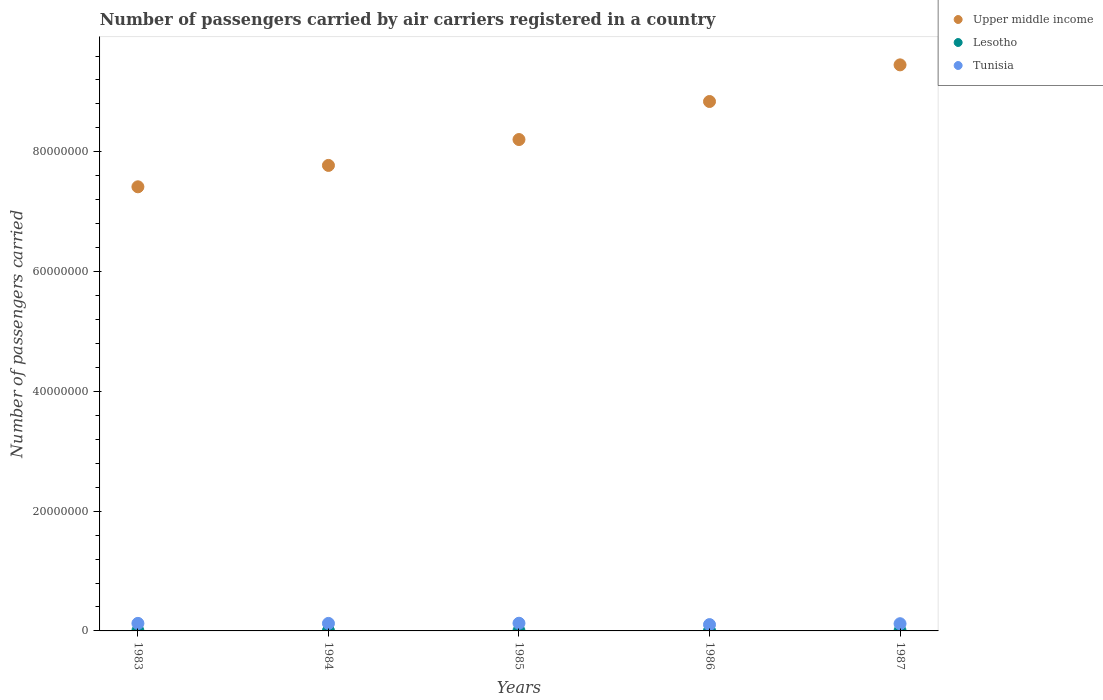Is the number of dotlines equal to the number of legend labels?
Provide a succinct answer. Yes. What is the number of passengers carried by air carriers in Tunisia in 1983?
Your answer should be compact. 1.26e+06. Across all years, what is the maximum number of passengers carried by air carriers in Upper middle income?
Your answer should be very brief. 9.45e+07. Across all years, what is the minimum number of passengers carried by air carriers in Lesotho?
Give a very brief answer. 4.87e+04. In which year was the number of passengers carried by air carriers in Tunisia maximum?
Offer a very short reply. 1985. In which year was the number of passengers carried by air carriers in Tunisia minimum?
Ensure brevity in your answer.  1986. What is the total number of passengers carried by air carriers in Lesotho in the graph?
Make the answer very short. 2.77e+05. What is the difference between the number of passengers carried by air carriers in Lesotho in 1984 and that in 1985?
Ensure brevity in your answer.  -2000. What is the difference between the number of passengers carried by air carriers in Upper middle income in 1984 and the number of passengers carried by air carriers in Tunisia in 1983?
Offer a very short reply. 7.65e+07. What is the average number of passengers carried by air carriers in Tunisia per year?
Offer a terse response. 1.21e+06. In the year 1984, what is the difference between the number of passengers carried by air carriers in Upper middle income and number of passengers carried by air carriers in Lesotho?
Keep it short and to the point. 7.77e+07. In how many years, is the number of passengers carried by air carriers in Upper middle income greater than 92000000?
Offer a very short reply. 1. What is the ratio of the number of passengers carried by air carriers in Lesotho in 1983 to that in 1985?
Your response must be concise. 1.2. Is the difference between the number of passengers carried by air carriers in Upper middle income in 1985 and 1987 greater than the difference between the number of passengers carried by air carriers in Lesotho in 1985 and 1987?
Make the answer very short. No. What is the difference between the highest and the lowest number of passengers carried by air carriers in Tunisia?
Make the answer very short. 2.27e+05. Is it the case that in every year, the sum of the number of passengers carried by air carriers in Lesotho and number of passengers carried by air carriers in Tunisia  is greater than the number of passengers carried by air carriers in Upper middle income?
Give a very brief answer. No. Does the number of passengers carried by air carriers in Lesotho monotonically increase over the years?
Provide a succinct answer. No. Is the number of passengers carried by air carriers in Upper middle income strictly less than the number of passengers carried by air carriers in Tunisia over the years?
Provide a succinct answer. No. How many years are there in the graph?
Provide a short and direct response. 5. What is the difference between two consecutive major ticks on the Y-axis?
Your answer should be compact. 2.00e+07. Are the values on the major ticks of Y-axis written in scientific E-notation?
Make the answer very short. No. Does the graph contain any zero values?
Give a very brief answer. No. Does the graph contain grids?
Offer a terse response. No. Where does the legend appear in the graph?
Offer a very short reply. Top right. How many legend labels are there?
Your answer should be compact. 3. How are the legend labels stacked?
Give a very brief answer. Vertical. What is the title of the graph?
Your response must be concise. Number of passengers carried by air carriers registered in a country. What is the label or title of the X-axis?
Your answer should be very brief. Years. What is the label or title of the Y-axis?
Provide a succinct answer. Number of passengers carried. What is the Number of passengers carried in Upper middle income in 1983?
Offer a very short reply. 7.42e+07. What is the Number of passengers carried of Lesotho in 1983?
Your answer should be very brief. 6.10e+04. What is the Number of passengers carried in Tunisia in 1983?
Keep it short and to the point. 1.26e+06. What is the Number of passengers carried in Upper middle income in 1984?
Provide a short and direct response. 7.77e+07. What is the Number of passengers carried in Lesotho in 1984?
Your answer should be compact. 4.87e+04. What is the Number of passengers carried of Tunisia in 1984?
Your answer should be very brief. 1.25e+06. What is the Number of passengers carried in Upper middle income in 1985?
Make the answer very short. 8.21e+07. What is the Number of passengers carried of Lesotho in 1985?
Ensure brevity in your answer.  5.07e+04. What is the Number of passengers carried of Tunisia in 1985?
Your answer should be compact. 1.28e+06. What is the Number of passengers carried of Upper middle income in 1986?
Provide a short and direct response. 8.84e+07. What is the Number of passengers carried of Lesotho in 1986?
Offer a terse response. 5.53e+04. What is the Number of passengers carried of Tunisia in 1986?
Give a very brief answer. 1.05e+06. What is the Number of passengers carried in Upper middle income in 1987?
Offer a very short reply. 9.45e+07. What is the Number of passengers carried of Lesotho in 1987?
Provide a short and direct response. 6.09e+04. What is the Number of passengers carried in Tunisia in 1987?
Offer a very short reply. 1.20e+06. Across all years, what is the maximum Number of passengers carried in Upper middle income?
Your answer should be compact. 9.45e+07. Across all years, what is the maximum Number of passengers carried in Lesotho?
Ensure brevity in your answer.  6.10e+04. Across all years, what is the maximum Number of passengers carried of Tunisia?
Offer a terse response. 1.28e+06. Across all years, what is the minimum Number of passengers carried in Upper middle income?
Offer a very short reply. 7.42e+07. Across all years, what is the minimum Number of passengers carried of Lesotho?
Keep it short and to the point. 4.87e+04. Across all years, what is the minimum Number of passengers carried in Tunisia?
Your answer should be compact. 1.05e+06. What is the total Number of passengers carried of Upper middle income in the graph?
Your response must be concise. 4.17e+08. What is the total Number of passengers carried in Lesotho in the graph?
Ensure brevity in your answer.  2.77e+05. What is the total Number of passengers carried in Tunisia in the graph?
Offer a terse response. 6.05e+06. What is the difference between the Number of passengers carried in Upper middle income in 1983 and that in 1984?
Your response must be concise. -3.57e+06. What is the difference between the Number of passengers carried in Lesotho in 1983 and that in 1984?
Keep it short and to the point. 1.23e+04. What is the difference between the Number of passengers carried in Tunisia in 1983 and that in 1984?
Provide a succinct answer. 3200. What is the difference between the Number of passengers carried in Upper middle income in 1983 and that in 1985?
Offer a terse response. -7.89e+06. What is the difference between the Number of passengers carried in Lesotho in 1983 and that in 1985?
Provide a succinct answer. 1.03e+04. What is the difference between the Number of passengers carried of Tunisia in 1983 and that in 1985?
Your answer should be compact. -2.35e+04. What is the difference between the Number of passengers carried of Upper middle income in 1983 and that in 1986?
Your answer should be compact. -1.42e+07. What is the difference between the Number of passengers carried of Lesotho in 1983 and that in 1986?
Provide a short and direct response. 5700. What is the difference between the Number of passengers carried of Tunisia in 1983 and that in 1986?
Give a very brief answer. 2.03e+05. What is the difference between the Number of passengers carried in Upper middle income in 1983 and that in 1987?
Provide a short and direct response. -2.04e+07. What is the difference between the Number of passengers carried in Lesotho in 1983 and that in 1987?
Offer a very short reply. 100. What is the difference between the Number of passengers carried of Tunisia in 1983 and that in 1987?
Make the answer very short. 5.48e+04. What is the difference between the Number of passengers carried in Upper middle income in 1984 and that in 1985?
Your response must be concise. -4.32e+06. What is the difference between the Number of passengers carried of Lesotho in 1984 and that in 1985?
Give a very brief answer. -2000. What is the difference between the Number of passengers carried in Tunisia in 1984 and that in 1985?
Give a very brief answer. -2.67e+04. What is the difference between the Number of passengers carried of Upper middle income in 1984 and that in 1986?
Provide a succinct answer. -1.07e+07. What is the difference between the Number of passengers carried of Lesotho in 1984 and that in 1986?
Your answer should be very brief. -6600. What is the difference between the Number of passengers carried of Tunisia in 1984 and that in 1986?
Offer a very short reply. 2.00e+05. What is the difference between the Number of passengers carried in Upper middle income in 1984 and that in 1987?
Your response must be concise. -1.68e+07. What is the difference between the Number of passengers carried of Lesotho in 1984 and that in 1987?
Your answer should be very brief. -1.22e+04. What is the difference between the Number of passengers carried of Tunisia in 1984 and that in 1987?
Keep it short and to the point. 5.16e+04. What is the difference between the Number of passengers carried in Upper middle income in 1985 and that in 1986?
Your response must be concise. -6.35e+06. What is the difference between the Number of passengers carried of Lesotho in 1985 and that in 1986?
Provide a short and direct response. -4600. What is the difference between the Number of passengers carried of Tunisia in 1985 and that in 1986?
Make the answer very short. 2.27e+05. What is the difference between the Number of passengers carried in Upper middle income in 1985 and that in 1987?
Your answer should be very brief. -1.25e+07. What is the difference between the Number of passengers carried in Lesotho in 1985 and that in 1987?
Your answer should be compact. -1.02e+04. What is the difference between the Number of passengers carried of Tunisia in 1985 and that in 1987?
Offer a terse response. 7.83e+04. What is the difference between the Number of passengers carried in Upper middle income in 1986 and that in 1987?
Offer a very short reply. -6.12e+06. What is the difference between the Number of passengers carried of Lesotho in 1986 and that in 1987?
Give a very brief answer. -5600. What is the difference between the Number of passengers carried of Tunisia in 1986 and that in 1987?
Your response must be concise. -1.48e+05. What is the difference between the Number of passengers carried of Upper middle income in 1983 and the Number of passengers carried of Lesotho in 1984?
Ensure brevity in your answer.  7.41e+07. What is the difference between the Number of passengers carried in Upper middle income in 1983 and the Number of passengers carried in Tunisia in 1984?
Provide a short and direct response. 7.29e+07. What is the difference between the Number of passengers carried in Lesotho in 1983 and the Number of passengers carried in Tunisia in 1984?
Your response must be concise. -1.19e+06. What is the difference between the Number of passengers carried of Upper middle income in 1983 and the Number of passengers carried of Lesotho in 1985?
Offer a very short reply. 7.41e+07. What is the difference between the Number of passengers carried of Upper middle income in 1983 and the Number of passengers carried of Tunisia in 1985?
Offer a terse response. 7.29e+07. What is the difference between the Number of passengers carried of Lesotho in 1983 and the Number of passengers carried of Tunisia in 1985?
Make the answer very short. -1.22e+06. What is the difference between the Number of passengers carried in Upper middle income in 1983 and the Number of passengers carried in Lesotho in 1986?
Provide a short and direct response. 7.41e+07. What is the difference between the Number of passengers carried in Upper middle income in 1983 and the Number of passengers carried in Tunisia in 1986?
Provide a short and direct response. 7.31e+07. What is the difference between the Number of passengers carried of Lesotho in 1983 and the Number of passengers carried of Tunisia in 1986?
Provide a succinct answer. -9.94e+05. What is the difference between the Number of passengers carried in Upper middle income in 1983 and the Number of passengers carried in Lesotho in 1987?
Your answer should be very brief. 7.41e+07. What is the difference between the Number of passengers carried in Upper middle income in 1983 and the Number of passengers carried in Tunisia in 1987?
Your response must be concise. 7.30e+07. What is the difference between the Number of passengers carried in Lesotho in 1983 and the Number of passengers carried in Tunisia in 1987?
Give a very brief answer. -1.14e+06. What is the difference between the Number of passengers carried in Upper middle income in 1984 and the Number of passengers carried in Lesotho in 1985?
Offer a terse response. 7.77e+07. What is the difference between the Number of passengers carried of Upper middle income in 1984 and the Number of passengers carried of Tunisia in 1985?
Provide a succinct answer. 7.65e+07. What is the difference between the Number of passengers carried in Lesotho in 1984 and the Number of passengers carried in Tunisia in 1985?
Provide a short and direct response. -1.23e+06. What is the difference between the Number of passengers carried in Upper middle income in 1984 and the Number of passengers carried in Lesotho in 1986?
Your response must be concise. 7.77e+07. What is the difference between the Number of passengers carried in Upper middle income in 1984 and the Number of passengers carried in Tunisia in 1986?
Your answer should be very brief. 7.67e+07. What is the difference between the Number of passengers carried of Lesotho in 1984 and the Number of passengers carried of Tunisia in 1986?
Your answer should be very brief. -1.01e+06. What is the difference between the Number of passengers carried of Upper middle income in 1984 and the Number of passengers carried of Lesotho in 1987?
Make the answer very short. 7.77e+07. What is the difference between the Number of passengers carried in Upper middle income in 1984 and the Number of passengers carried in Tunisia in 1987?
Give a very brief answer. 7.65e+07. What is the difference between the Number of passengers carried of Lesotho in 1984 and the Number of passengers carried of Tunisia in 1987?
Give a very brief answer. -1.15e+06. What is the difference between the Number of passengers carried in Upper middle income in 1985 and the Number of passengers carried in Lesotho in 1986?
Offer a terse response. 8.20e+07. What is the difference between the Number of passengers carried of Upper middle income in 1985 and the Number of passengers carried of Tunisia in 1986?
Provide a succinct answer. 8.10e+07. What is the difference between the Number of passengers carried in Lesotho in 1985 and the Number of passengers carried in Tunisia in 1986?
Give a very brief answer. -1.00e+06. What is the difference between the Number of passengers carried of Upper middle income in 1985 and the Number of passengers carried of Lesotho in 1987?
Offer a terse response. 8.20e+07. What is the difference between the Number of passengers carried in Upper middle income in 1985 and the Number of passengers carried in Tunisia in 1987?
Your answer should be very brief. 8.08e+07. What is the difference between the Number of passengers carried in Lesotho in 1985 and the Number of passengers carried in Tunisia in 1987?
Keep it short and to the point. -1.15e+06. What is the difference between the Number of passengers carried in Upper middle income in 1986 and the Number of passengers carried in Lesotho in 1987?
Provide a succinct answer. 8.83e+07. What is the difference between the Number of passengers carried in Upper middle income in 1986 and the Number of passengers carried in Tunisia in 1987?
Your response must be concise. 8.72e+07. What is the difference between the Number of passengers carried of Lesotho in 1986 and the Number of passengers carried of Tunisia in 1987?
Give a very brief answer. -1.15e+06. What is the average Number of passengers carried in Upper middle income per year?
Keep it short and to the point. 8.34e+07. What is the average Number of passengers carried in Lesotho per year?
Provide a succinct answer. 5.53e+04. What is the average Number of passengers carried in Tunisia per year?
Give a very brief answer. 1.21e+06. In the year 1983, what is the difference between the Number of passengers carried in Upper middle income and Number of passengers carried in Lesotho?
Your response must be concise. 7.41e+07. In the year 1983, what is the difference between the Number of passengers carried in Upper middle income and Number of passengers carried in Tunisia?
Provide a short and direct response. 7.29e+07. In the year 1983, what is the difference between the Number of passengers carried in Lesotho and Number of passengers carried in Tunisia?
Provide a succinct answer. -1.20e+06. In the year 1984, what is the difference between the Number of passengers carried in Upper middle income and Number of passengers carried in Lesotho?
Offer a very short reply. 7.77e+07. In the year 1984, what is the difference between the Number of passengers carried in Upper middle income and Number of passengers carried in Tunisia?
Offer a terse response. 7.65e+07. In the year 1984, what is the difference between the Number of passengers carried of Lesotho and Number of passengers carried of Tunisia?
Make the answer very short. -1.21e+06. In the year 1985, what is the difference between the Number of passengers carried in Upper middle income and Number of passengers carried in Lesotho?
Make the answer very short. 8.20e+07. In the year 1985, what is the difference between the Number of passengers carried in Upper middle income and Number of passengers carried in Tunisia?
Your answer should be very brief. 8.08e+07. In the year 1985, what is the difference between the Number of passengers carried in Lesotho and Number of passengers carried in Tunisia?
Your response must be concise. -1.23e+06. In the year 1986, what is the difference between the Number of passengers carried of Upper middle income and Number of passengers carried of Lesotho?
Offer a terse response. 8.83e+07. In the year 1986, what is the difference between the Number of passengers carried in Upper middle income and Number of passengers carried in Tunisia?
Give a very brief answer. 8.74e+07. In the year 1986, what is the difference between the Number of passengers carried in Lesotho and Number of passengers carried in Tunisia?
Ensure brevity in your answer.  -1.00e+06. In the year 1987, what is the difference between the Number of passengers carried of Upper middle income and Number of passengers carried of Lesotho?
Ensure brevity in your answer.  9.45e+07. In the year 1987, what is the difference between the Number of passengers carried of Upper middle income and Number of passengers carried of Tunisia?
Keep it short and to the point. 9.33e+07. In the year 1987, what is the difference between the Number of passengers carried of Lesotho and Number of passengers carried of Tunisia?
Offer a very short reply. -1.14e+06. What is the ratio of the Number of passengers carried of Upper middle income in 1983 to that in 1984?
Provide a succinct answer. 0.95. What is the ratio of the Number of passengers carried in Lesotho in 1983 to that in 1984?
Provide a succinct answer. 1.25. What is the ratio of the Number of passengers carried of Tunisia in 1983 to that in 1984?
Provide a short and direct response. 1. What is the ratio of the Number of passengers carried in Upper middle income in 1983 to that in 1985?
Offer a terse response. 0.9. What is the ratio of the Number of passengers carried of Lesotho in 1983 to that in 1985?
Your answer should be compact. 1.2. What is the ratio of the Number of passengers carried in Tunisia in 1983 to that in 1985?
Make the answer very short. 0.98. What is the ratio of the Number of passengers carried in Upper middle income in 1983 to that in 1986?
Ensure brevity in your answer.  0.84. What is the ratio of the Number of passengers carried of Lesotho in 1983 to that in 1986?
Your answer should be very brief. 1.1. What is the ratio of the Number of passengers carried of Tunisia in 1983 to that in 1986?
Provide a short and direct response. 1.19. What is the ratio of the Number of passengers carried of Upper middle income in 1983 to that in 1987?
Provide a short and direct response. 0.78. What is the ratio of the Number of passengers carried in Tunisia in 1983 to that in 1987?
Provide a short and direct response. 1.05. What is the ratio of the Number of passengers carried in Upper middle income in 1984 to that in 1985?
Ensure brevity in your answer.  0.95. What is the ratio of the Number of passengers carried in Lesotho in 1984 to that in 1985?
Keep it short and to the point. 0.96. What is the ratio of the Number of passengers carried of Tunisia in 1984 to that in 1985?
Keep it short and to the point. 0.98. What is the ratio of the Number of passengers carried in Upper middle income in 1984 to that in 1986?
Give a very brief answer. 0.88. What is the ratio of the Number of passengers carried in Lesotho in 1984 to that in 1986?
Offer a very short reply. 0.88. What is the ratio of the Number of passengers carried of Tunisia in 1984 to that in 1986?
Provide a short and direct response. 1.19. What is the ratio of the Number of passengers carried in Upper middle income in 1984 to that in 1987?
Your answer should be compact. 0.82. What is the ratio of the Number of passengers carried of Lesotho in 1984 to that in 1987?
Provide a short and direct response. 0.8. What is the ratio of the Number of passengers carried of Tunisia in 1984 to that in 1987?
Your response must be concise. 1.04. What is the ratio of the Number of passengers carried of Upper middle income in 1985 to that in 1986?
Give a very brief answer. 0.93. What is the ratio of the Number of passengers carried in Lesotho in 1985 to that in 1986?
Make the answer very short. 0.92. What is the ratio of the Number of passengers carried of Tunisia in 1985 to that in 1986?
Make the answer very short. 1.22. What is the ratio of the Number of passengers carried of Upper middle income in 1985 to that in 1987?
Give a very brief answer. 0.87. What is the ratio of the Number of passengers carried of Lesotho in 1985 to that in 1987?
Your response must be concise. 0.83. What is the ratio of the Number of passengers carried in Tunisia in 1985 to that in 1987?
Provide a short and direct response. 1.07. What is the ratio of the Number of passengers carried in Upper middle income in 1986 to that in 1987?
Provide a succinct answer. 0.94. What is the ratio of the Number of passengers carried of Lesotho in 1986 to that in 1987?
Ensure brevity in your answer.  0.91. What is the ratio of the Number of passengers carried in Tunisia in 1986 to that in 1987?
Your response must be concise. 0.88. What is the difference between the highest and the second highest Number of passengers carried of Upper middle income?
Your answer should be very brief. 6.12e+06. What is the difference between the highest and the second highest Number of passengers carried of Tunisia?
Keep it short and to the point. 2.35e+04. What is the difference between the highest and the lowest Number of passengers carried of Upper middle income?
Offer a very short reply. 2.04e+07. What is the difference between the highest and the lowest Number of passengers carried in Lesotho?
Make the answer very short. 1.23e+04. What is the difference between the highest and the lowest Number of passengers carried in Tunisia?
Provide a succinct answer. 2.27e+05. 